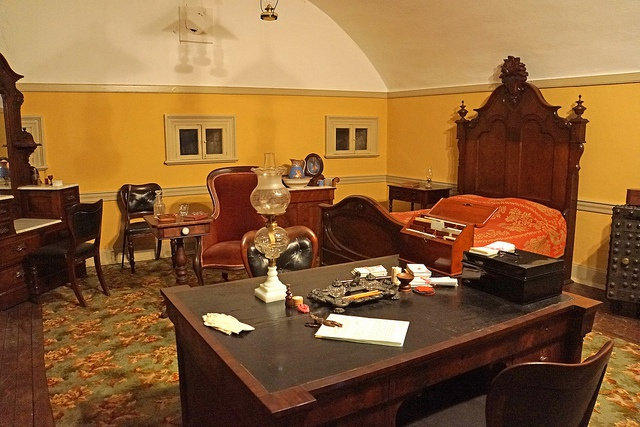Describe the objects in this image and their specific colors. I can see bed in tan, black, red, and maroon tones, chair in tan, black, maroon, and brown tones, chair in tan, maroon, and brown tones, chair in tan, black, and maroon tones, and chair in tan, maroon, black, and brown tones in this image. 